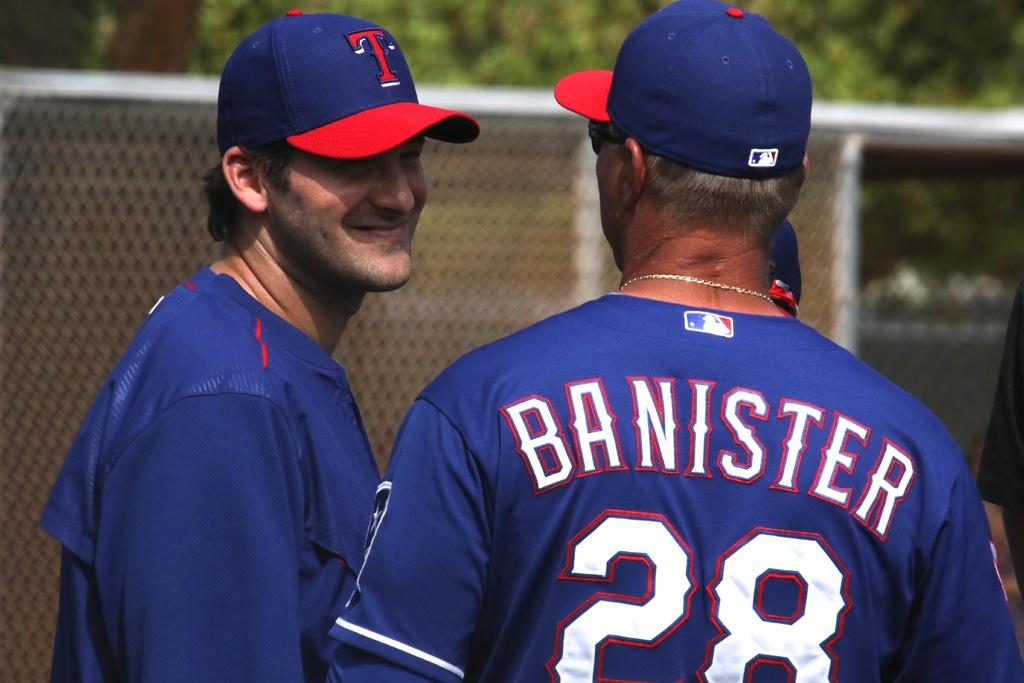What is the number on the players back ?
Make the answer very short. 28. What is the name on the players back?
Make the answer very short. Banister. 